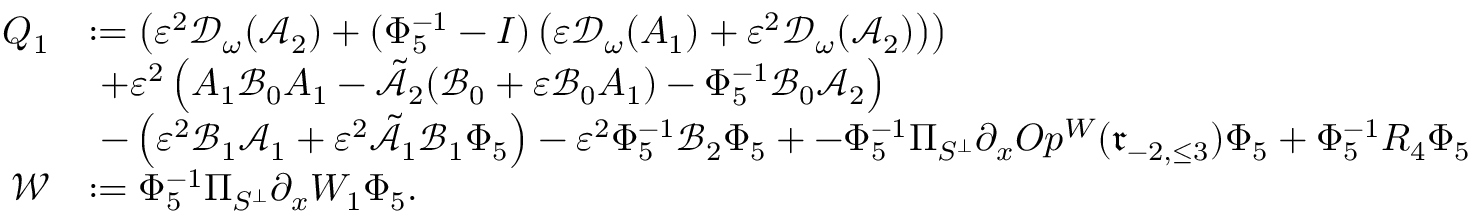<formula> <loc_0><loc_0><loc_500><loc_500>\begin{array} { r l } { { Q } _ { 1 } } & { \colon = \left ( \varepsilon ^ { 2 } \mathcal { D } _ { \omega } ( \mathcal { A } _ { 2 } ) + ( \Phi _ { 5 } ^ { - 1 } - I ) \left ( \varepsilon \mathcal { D } _ { \omega } ( A _ { 1 } ) + \varepsilon ^ { 2 } \mathcal { D } _ { \omega } ( \mathcal { A } _ { 2 } ) \right ) \right ) } \\ & { \ + \varepsilon ^ { 2 } \left ( A _ { 1 } \mathcal { B } _ { 0 } A _ { 1 } - \tilde { \mathcal { A } _ { 2 } } ( \mathcal { B } _ { 0 } + \varepsilon \mathcal { B } _ { 0 } A _ { 1 } ) - \Phi _ { 5 } ^ { - 1 } \mathcal { B } _ { 0 } \mathcal { A } _ { 2 } \right ) } \\ & { \ - \left ( \varepsilon ^ { 2 } \mathcal { B } _ { 1 } \mathcal { A } _ { 1 } + \varepsilon ^ { 2 } \tilde { \mathcal { A } } _ { 1 } \mathcal { B } _ { 1 } \Phi _ { 5 } \right ) - \varepsilon ^ { 2 } \Phi _ { 5 } ^ { - 1 } \mathcal { B } _ { 2 } \Phi _ { 5 } + - \Phi _ { 5 } ^ { - 1 } \Pi _ { S ^ { \perp } } \partial _ { x } O p ^ { W } ( \mathfrak { r } _ { - 2 , \leq 3 } ) \Phi _ { 5 } + \Phi _ { 5 } ^ { - 1 } R _ { 4 } \Phi _ { 5 } } \\ { \mathcal { W } } & { \colon = \Phi _ { 5 } ^ { - 1 } \Pi _ { S ^ { \perp } } \partial _ { x } W _ { 1 } \Phi _ { 5 } . } \end{array}</formula> 